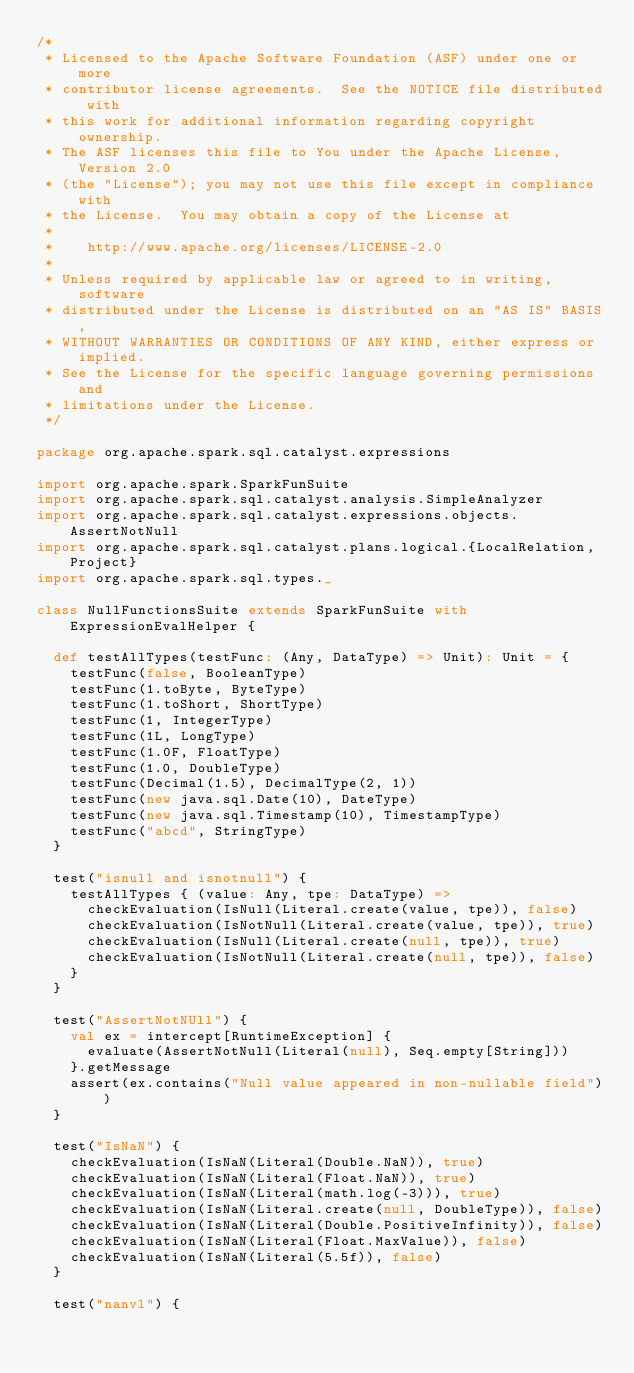<code> <loc_0><loc_0><loc_500><loc_500><_Scala_>/*
 * Licensed to the Apache Software Foundation (ASF) under one or more
 * contributor license agreements.  See the NOTICE file distributed with
 * this work for additional information regarding copyright ownership.
 * The ASF licenses this file to You under the Apache License, Version 2.0
 * (the "License"); you may not use this file except in compliance with
 * the License.  You may obtain a copy of the License at
 *
 *    http://www.apache.org/licenses/LICENSE-2.0
 *
 * Unless required by applicable law or agreed to in writing, software
 * distributed under the License is distributed on an "AS IS" BASIS,
 * WITHOUT WARRANTIES OR CONDITIONS OF ANY KIND, either express or implied.
 * See the License for the specific language governing permissions and
 * limitations under the License.
 */

package org.apache.spark.sql.catalyst.expressions

import org.apache.spark.SparkFunSuite
import org.apache.spark.sql.catalyst.analysis.SimpleAnalyzer
import org.apache.spark.sql.catalyst.expressions.objects.AssertNotNull
import org.apache.spark.sql.catalyst.plans.logical.{LocalRelation, Project}
import org.apache.spark.sql.types._

class NullFunctionsSuite extends SparkFunSuite with ExpressionEvalHelper {

  def testAllTypes(testFunc: (Any, DataType) => Unit): Unit = {
    testFunc(false, BooleanType)
    testFunc(1.toByte, ByteType)
    testFunc(1.toShort, ShortType)
    testFunc(1, IntegerType)
    testFunc(1L, LongType)
    testFunc(1.0F, FloatType)
    testFunc(1.0, DoubleType)
    testFunc(Decimal(1.5), DecimalType(2, 1))
    testFunc(new java.sql.Date(10), DateType)
    testFunc(new java.sql.Timestamp(10), TimestampType)
    testFunc("abcd", StringType)
  }

  test("isnull and isnotnull") {
    testAllTypes { (value: Any, tpe: DataType) =>
      checkEvaluation(IsNull(Literal.create(value, tpe)), false)
      checkEvaluation(IsNotNull(Literal.create(value, tpe)), true)
      checkEvaluation(IsNull(Literal.create(null, tpe)), true)
      checkEvaluation(IsNotNull(Literal.create(null, tpe)), false)
    }
  }

  test("AssertNotNUll") {
    val ex = intercept[RuntimeException] {
      evaluate(AssertNotNull(Literal(null), Seq.empty[String]))
    }.getMessage
    assert(ex.contains("Null value appeared in non-nullable field"))
  }

  test("IsNaN") {
    checkEvaluation(IsNaN(Literal(Double.NaN)), true)
    checkEvaluation(IsNaN(Literal(Float.NaN)), true)
    checkEvaluation(IsNaN(Literal(math.log(-3))), true)
    checkEvaluation(IsNaN(Literal.create(null, DoubleType)), false)
    checkEvaluation(IsNaN(Literal(Double.PositiveInfinity)), false)
    checkEvaluation(IsNaN(Literal(Float.MaxValue)), false)
    checkEvaluation(IsNaN(Literal(5.5f)), false)
  }

  test("nanvl") {</code> 